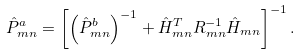Convert formula to latex. <formula><loc_0><loc_0><loc_500><loc_500>\hat { P } ^ { a } _ { m n } = \left [ \left ( \hat { P } ^ { b } _ { m n } \right ) ^ { - 1 } + \hat { H } ^ { T } _ { m n } R _ { m n } ^ { - 1 } \hat { H } _ { m n } \right ] ^ { - 1 } .</formula> 